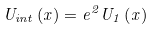Convert formula to latex. <formula><loc_0><loc_0><loc_500><loc_500>U _ { i n t } \left ( x \right ) = e ^ { 2 } U _ { 1 } \left ( x \right )</formula> 